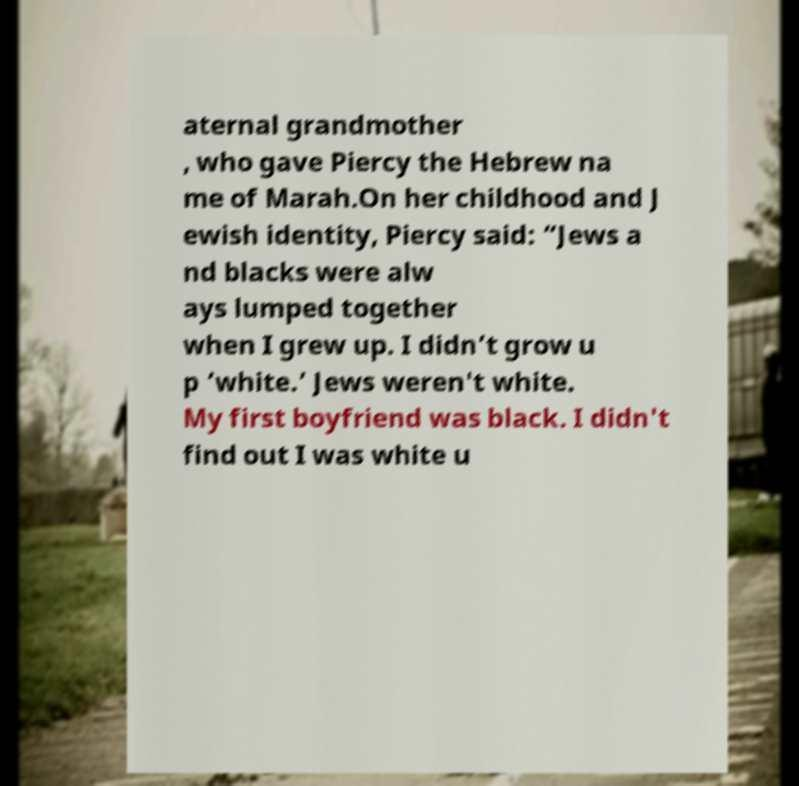Can you accurately transcribe the text from the provided image for me? aternal grandmother , who gave Piercy the Hebrew na me of Marah.On her childhood and J ewish identity, Piercy said: “Jews a nd blacks were alw ays lumped together when I grew up. I didn’t grow u p ‘white.’ Jews weren't white. My first boyfriend was black. I didn't find out I was white u 